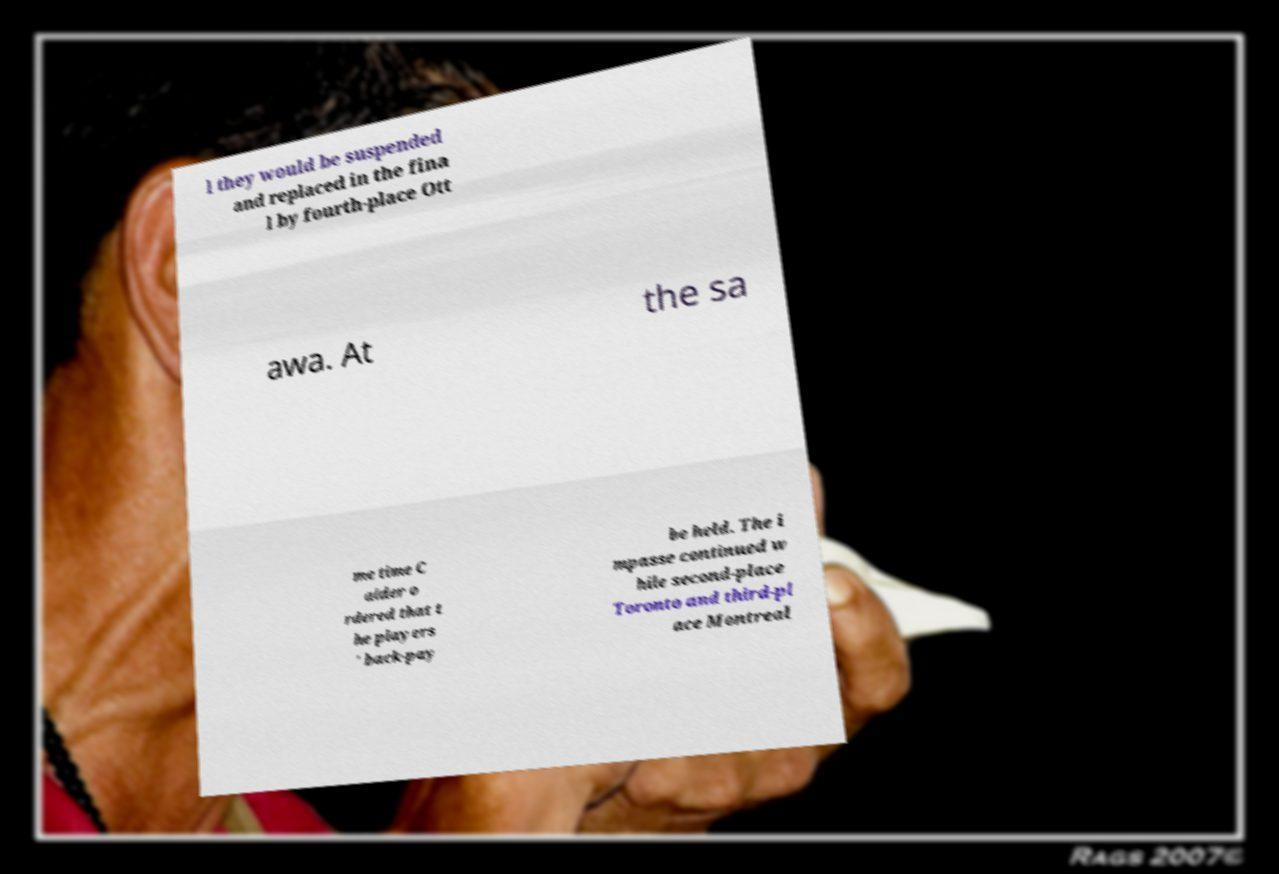There's text embedded in this image that I need extracted. Can you transcribe it verbatim? l they would be suspended and replaced in the fina l by fourth-place Ott awa. At the sa me time C alder o rdered that t he players ' back-pay be held. The i mpasse continued w hile second-place Toronto and third-pl ace Montreal 